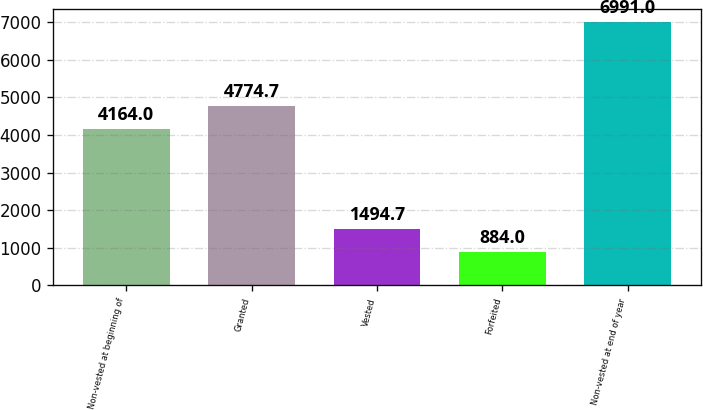Convert chart. <chart><loc_0><loc_0><loc_500><loc_500><bar_chart><fcel>Non-vested at beginning of<fcel>Granted<fcel>Vested<fcel>Forfeited<fcel>Non-vested at end of year<nl><fcel>4164<fcel>4774.7<fcel>1494.7<fcel>884<fcel>6991<nl></chart> 